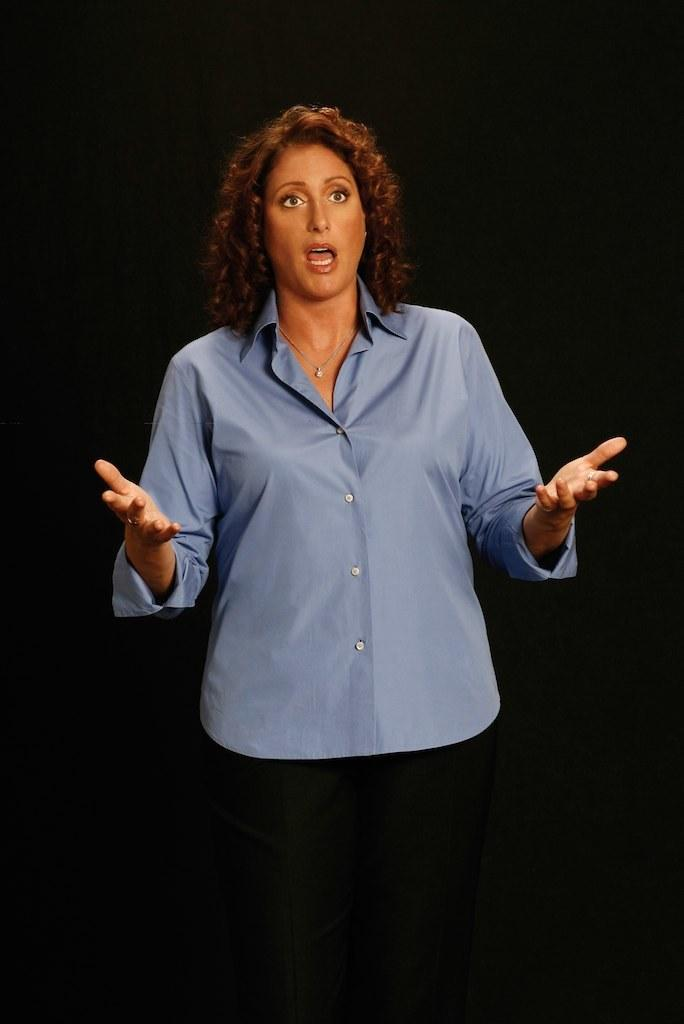Who is the main subject in the image? There is a woman in the image. What can be observed about the background of the image? The background of the image is dark. What type of verse can be heard in the background of the image? There is no verse present in the image, as it is a still photograph. 